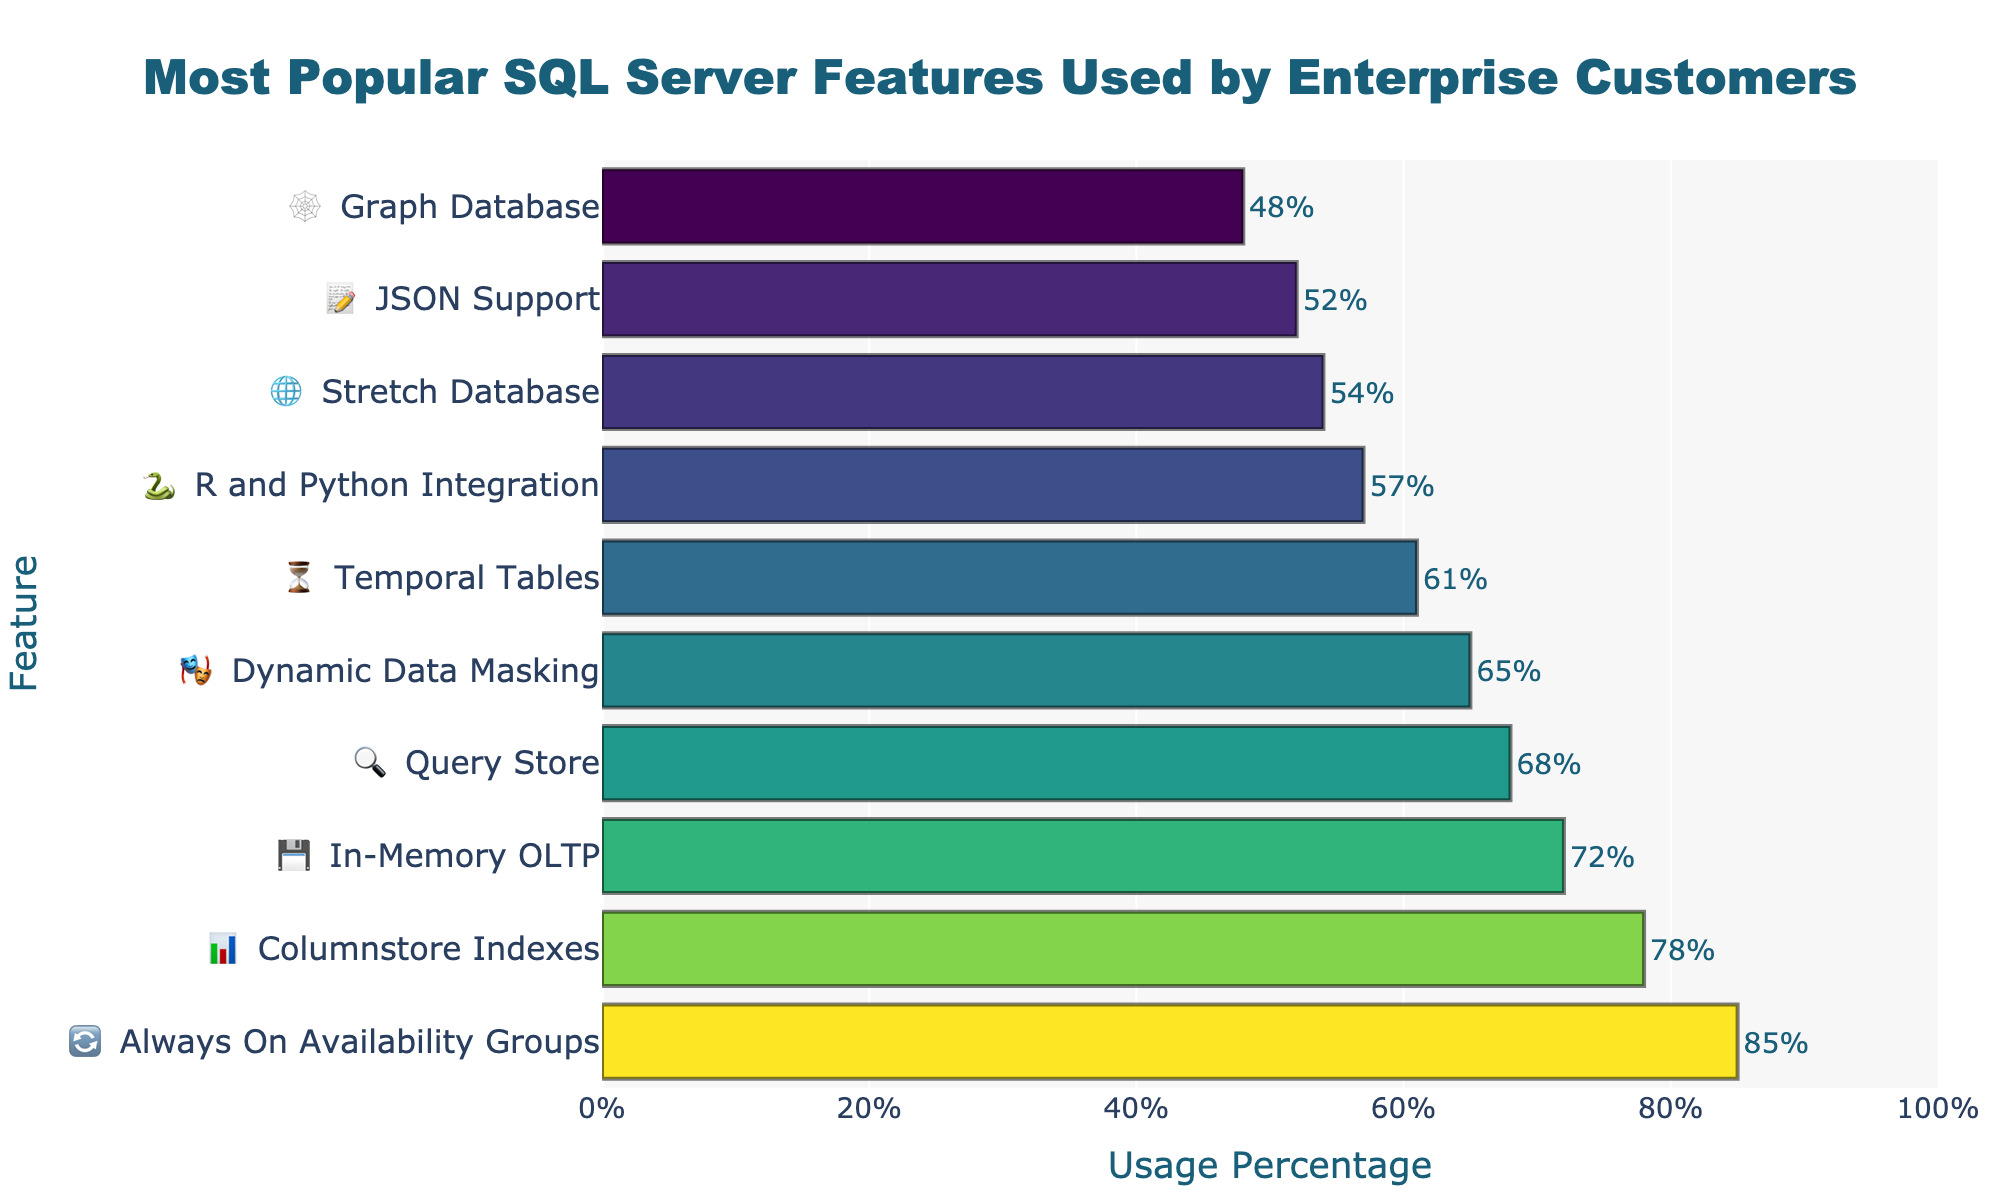what is the title of the chart? The title of the chart is usually placed at the top, centered, and it describes the overall content or subject of the chart. Here, it is "Most Popular SQL Server Features Used by Enterprise Customers"
Answer: Most Popular SQL Server Features Used by Enterprise Customers what percentage of enterprise customers use Always On Availability Groups? From the given chart, find the feature labeled "🔄 Always On Availability Groups" and look at the corresponding percentage on the x-axis. It shows 85%.
Answer: 85% How many features have a usage percentage greater than 70%? Identify all the features whose bars extend beyond the 70% mark on the x-axis. These are Always On Availability Groups, Columnstore Indexes, and In-Memory OLTP.
Answer: 3 Which feature has the lowest usage percentage? Locate the feature with the shortest bar on the chart. This corresponds to the lowest value, which is Graph Database with 48%.
Answer: Graph Database What is the difference in usage percentage between Query Store and Dynamic Data Masking? Find the percentages for Query Store (68%) and Dynamic Data Masking (65%) and subtract the smaller value from the larger one: 68% - 65% = 3%.
Answer: 3% How many unique emojis are used in the chart? Count the distinct emojis associated with each feature. There is a unique emoji for each of the 10 features.
Answer: 10 What is the average usage percentage of the features listed? Sum all usage percentages: 85% + 78% + 72% + 68% + 65% + 61% + 57% + 54% + 52% + 48% = 640%. Divide by the number of features, which is 10: 640% / 10 = 64%.
Answer: 64% Which feature is more widely used, R and Python Integration or JSON Support? Compare the usage percentages of R and Python Integration (57%) and JSON Support (52%). The feature with the higher percentage is R and Python Integration.
Answer: R and Python Integration 